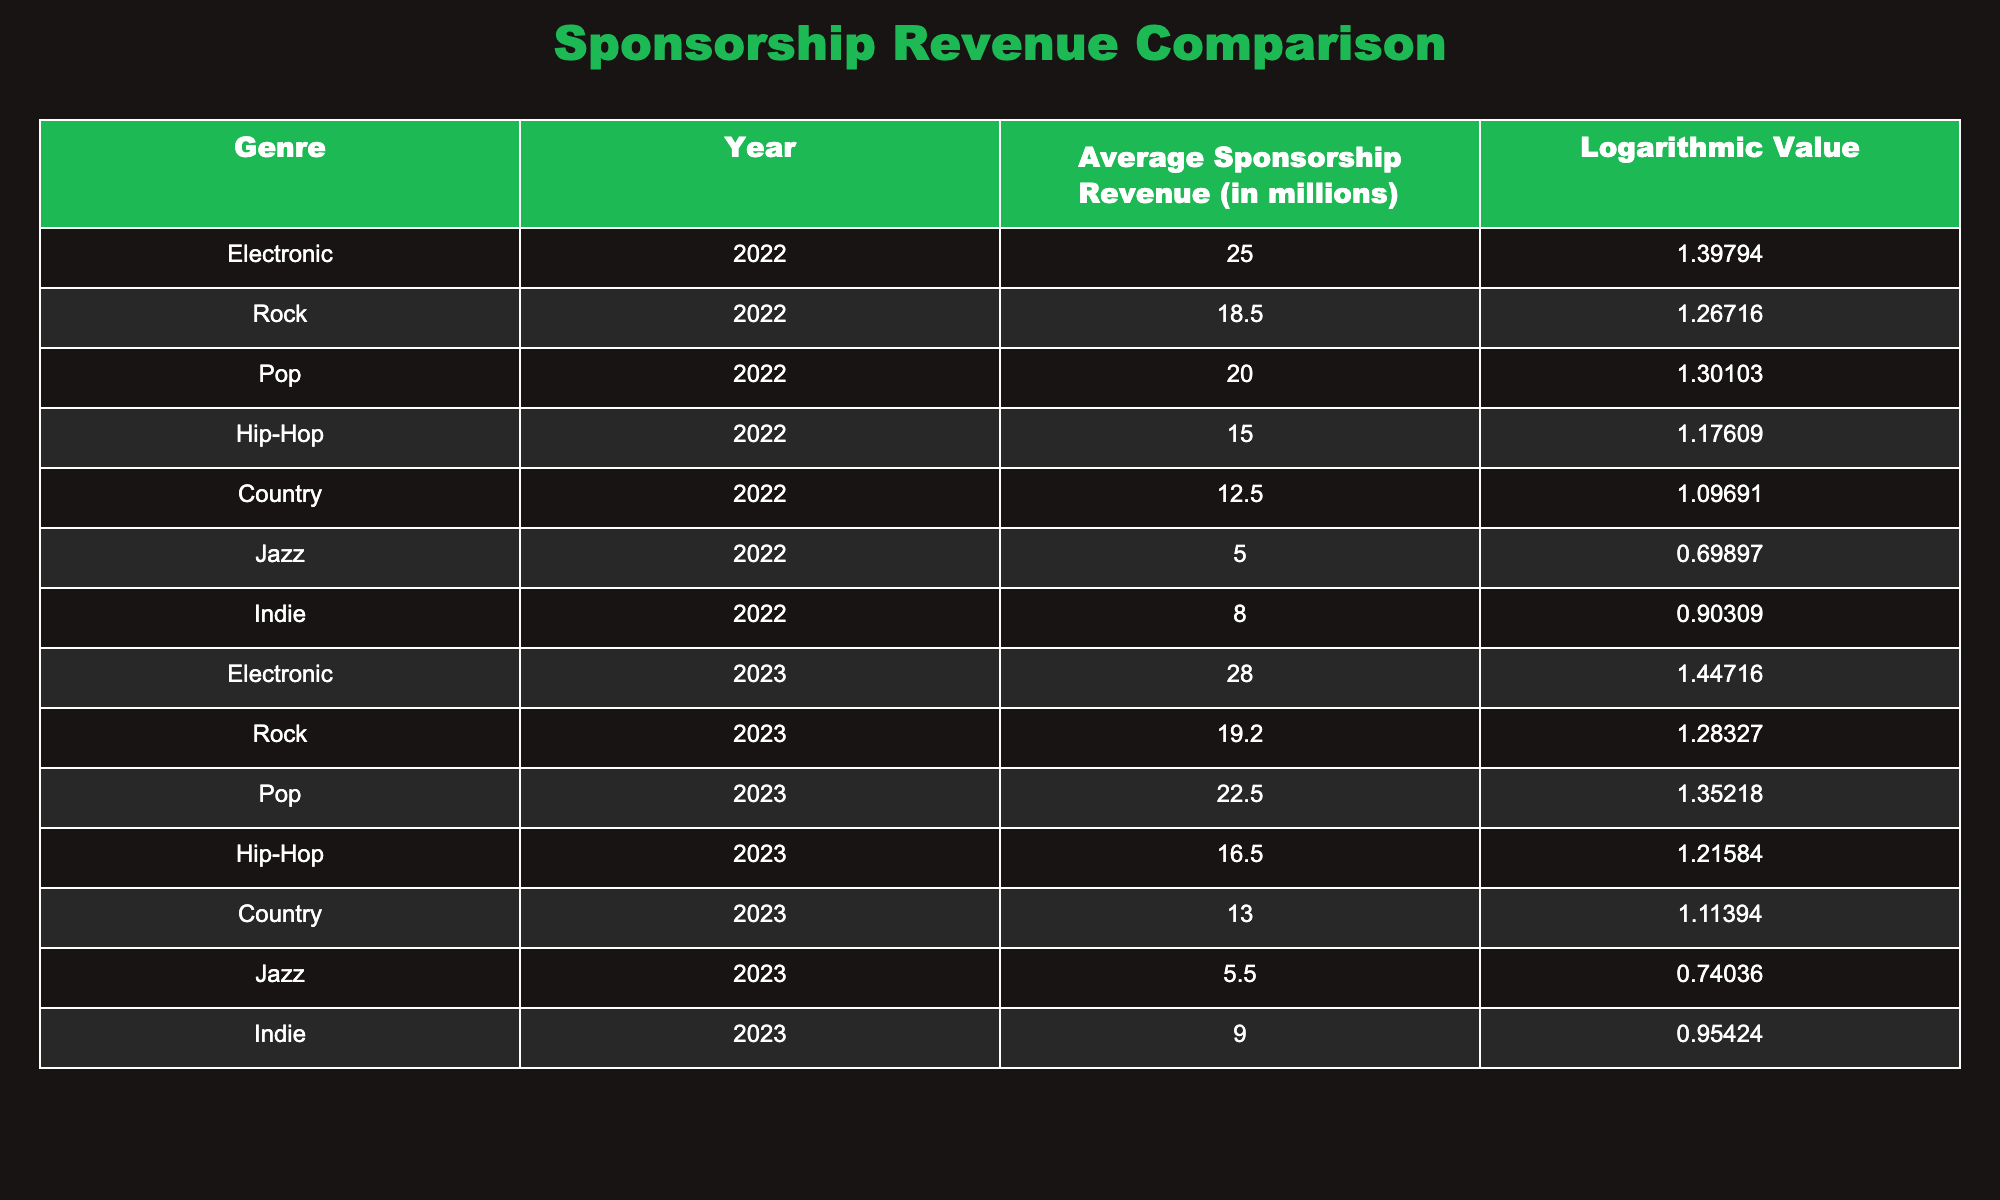What was the average sponsorship revenue for electronic music festivals in 2022? The table shows that the average sponsorship revenue for electronic music in 2022 is directly listed as 25.0 million.
Answer: 25.0 million How much higher was the sponsorship revenue for electronic music festivals in 2023 compared to 2022? In 2023, the average sponsorship revenue for electronic music is 28.0 million, and in 2022, it was 25.0 million. The difference is 28.0 - 25.0 = 3.0 million.
Answer: 3.0 million Which genre had the highest sponsorship revenue in 2022? By reviewing the table, electronic music with 25.0 million had the highest sponsorship revenue among listed genres for 2022.
Answer: Electronic Is there a genre whose average sponsorship revenue was below 10 million in 2022? Looking through the data, jazz with 5.0 million and indie with 8.0 million both have averages below 10 million in 2022. Hence, the answer is yes.
Answer: Yes What is the difference between the average sponsorship revenues of pop and rock in 2023? In 2023, pop had an average revenue of 22.5 million while rock had 19.2 million. The difference is 22.5 - 19.2 = 3.3 million, indicating that pop revenue exceeded rock revenue by this amount.
Answer: 3.3 million In which year was the average sponsorship revenue for country music higher, 2022 or 2023? The average sponsorship revenue for country music was 12.5 million in 2022 and increased to 13.0 million in 2023, hence 2023 had a higher average.
Answer: 2023 How much did the average sponsorship revenue for hip-hop festivals increase from 2022 to 2023? The average for hip-hop in 2022 was 15.0 million, and in 2023 it raised to 16.5 million. The increase is 16.5 - 15.0 = 1.5 million.
Answer: 1.5 million Which genre saw a decrease in average sponsorship revenue from 2022 to 2023? Examining the data, jazz had an average of 5.0 million in 2022 and increased to 5.5 million in 2023, while other genres either increased or did not yield a decrease, confirming no genre saw a decrease.
Answer: No genre had a decrease 